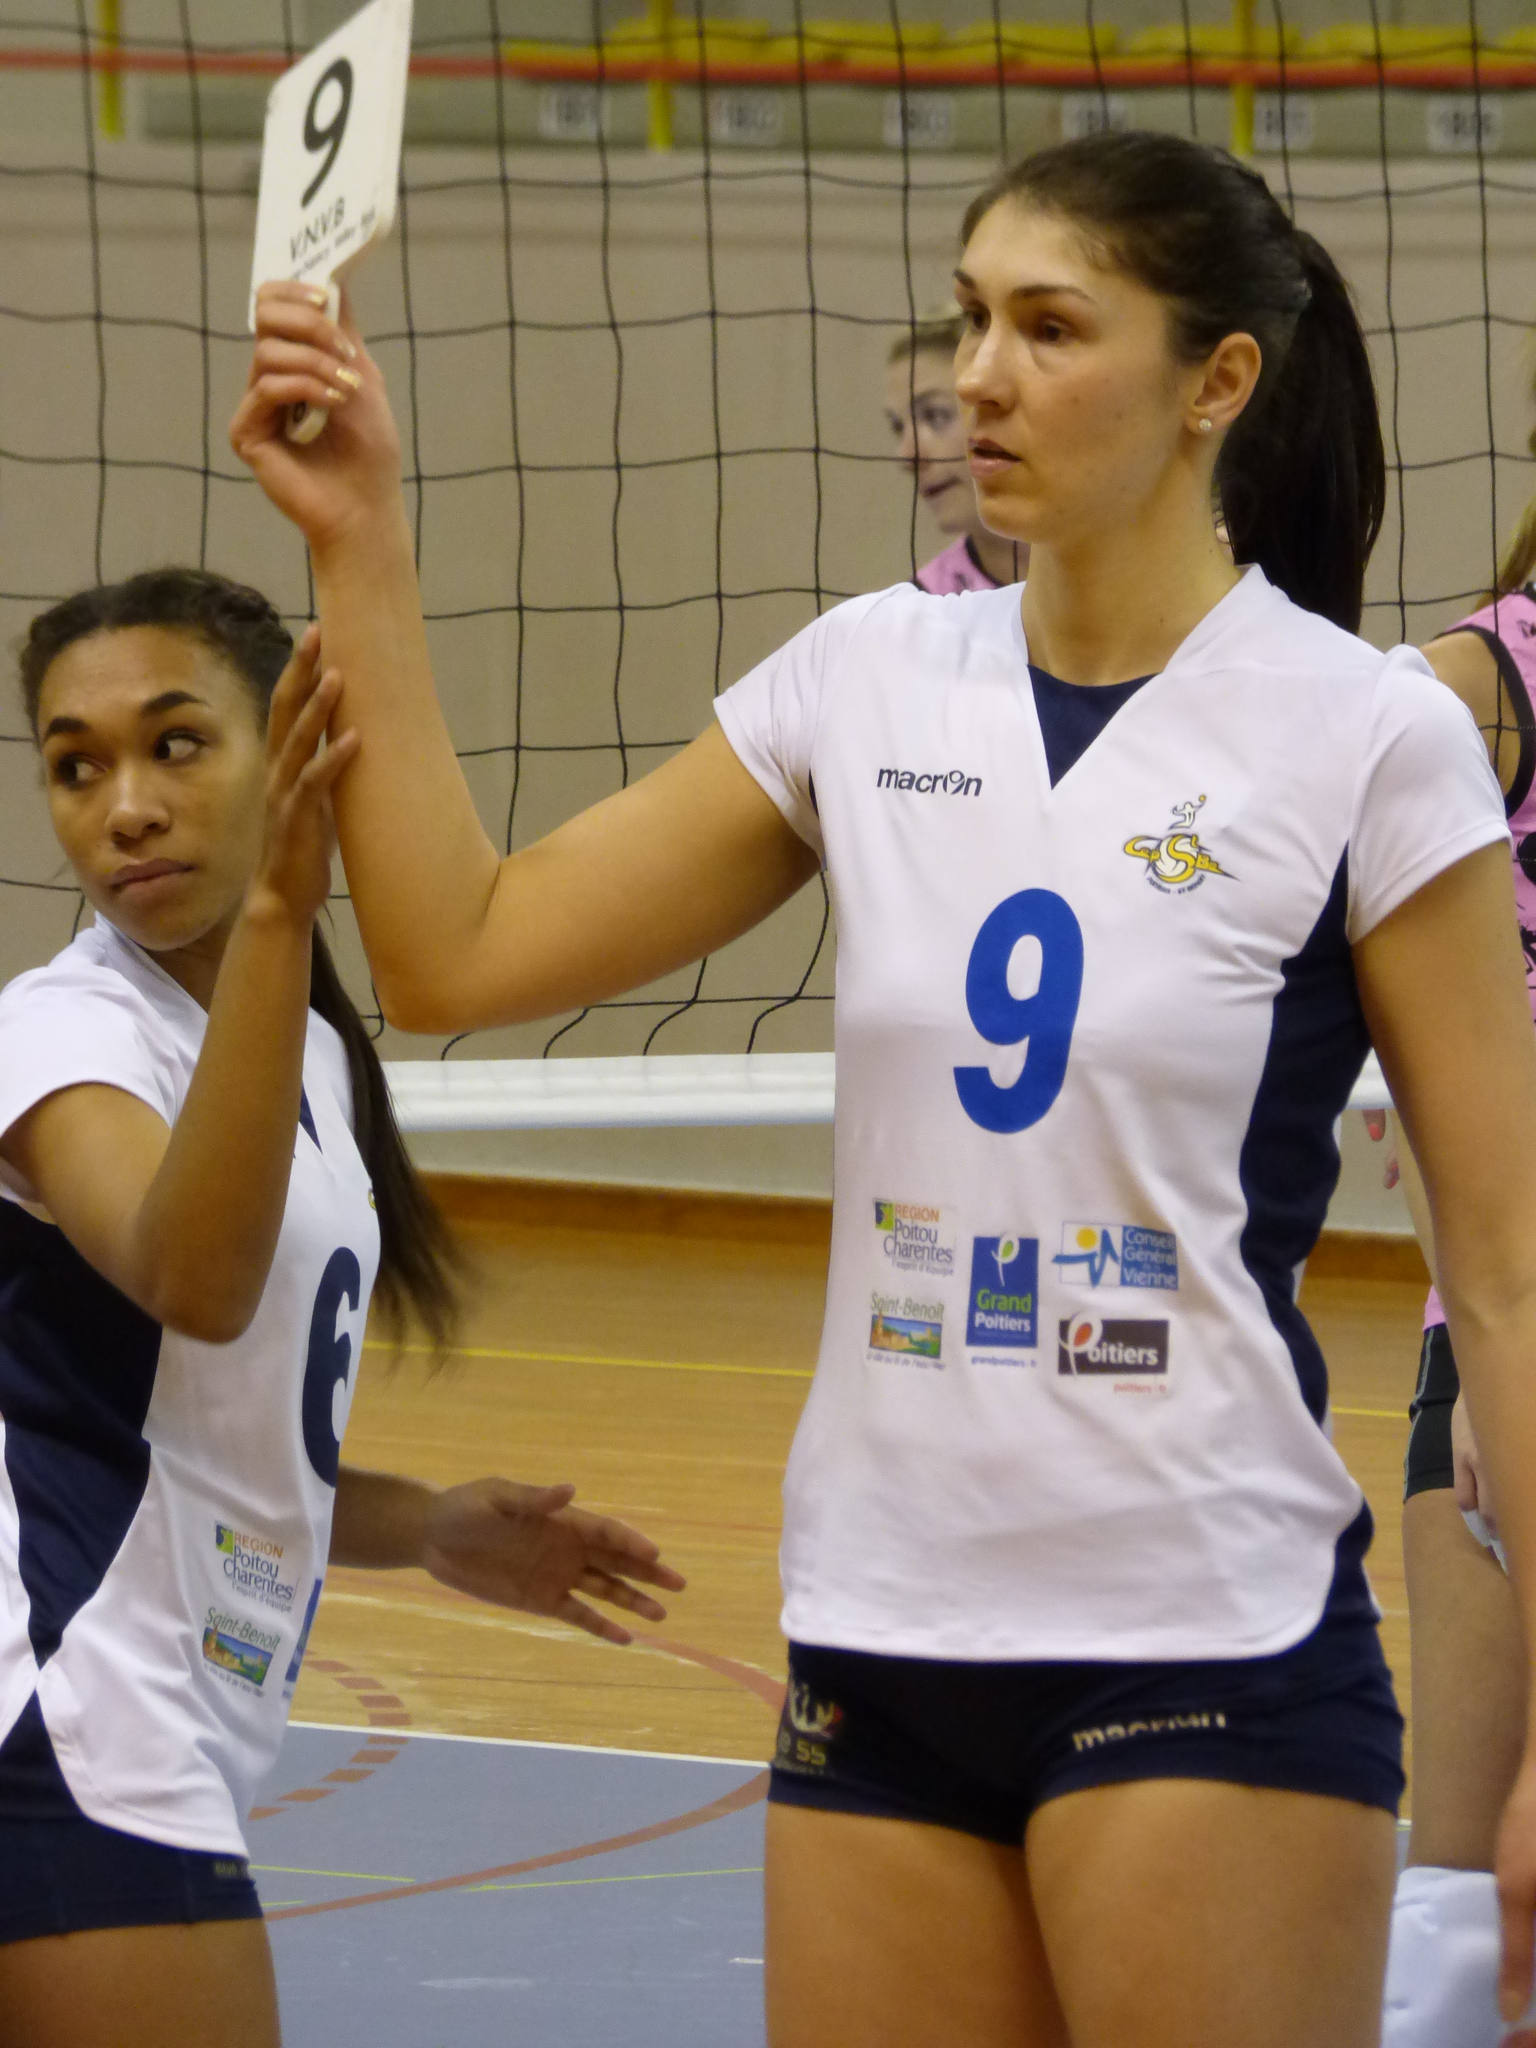<image>
Relay a brief, clear account of the picture shown. A player in a volleyball game holds up a card with the number 9 on it. 